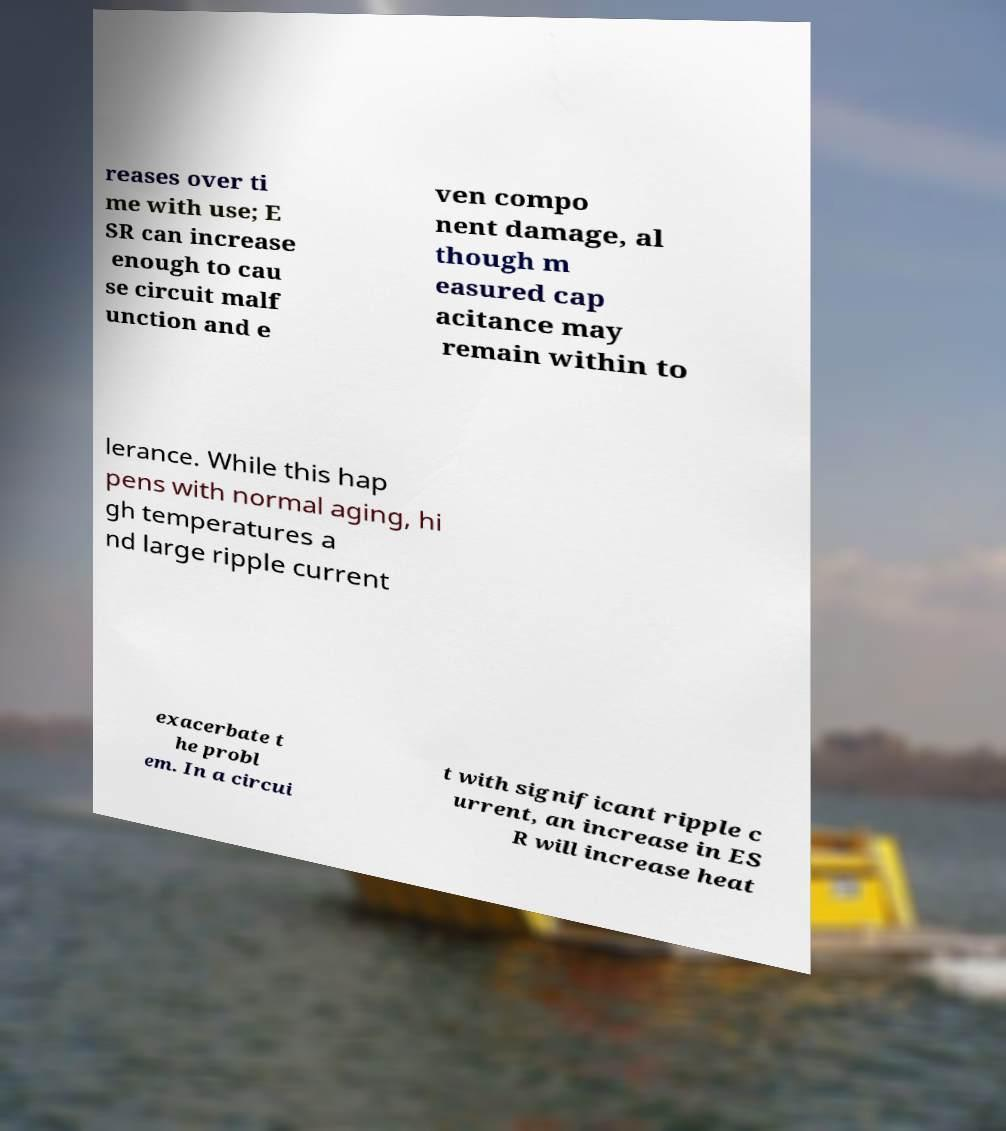What messages or text are displayed in this image? I need them in a readable, typed format. reases over ti me with use; E SR can increase enough to cau se circuit malf unction and e ven compo nent damage, al though m easured cap acitance may remain within to lerance. While this hap pens with normal aging, hi gh temperatures a nd large ripple current exacerbate t he probl em. In a circui t with significant ripple c urrent, an increase in ES R will increase heat 